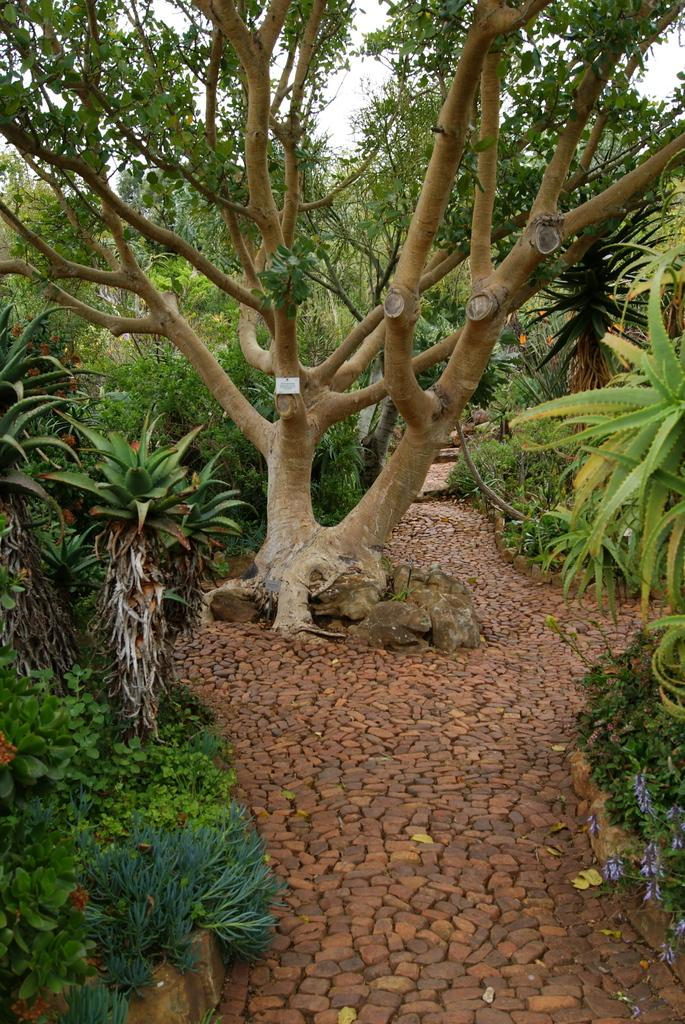What type of vegetation is present in the image? There are trees and plants in the image. What color are the trees and plants in the image? The trees and plants are green in color. What can be seen in the background of the image? The sky is visible in the background of the image. What color is the sky in the image? The sky is white in color. What type of apple is being sold at the attraction in the image? There is no apple or attraction present in the image; it features trees and plants with a white sky in the background. 